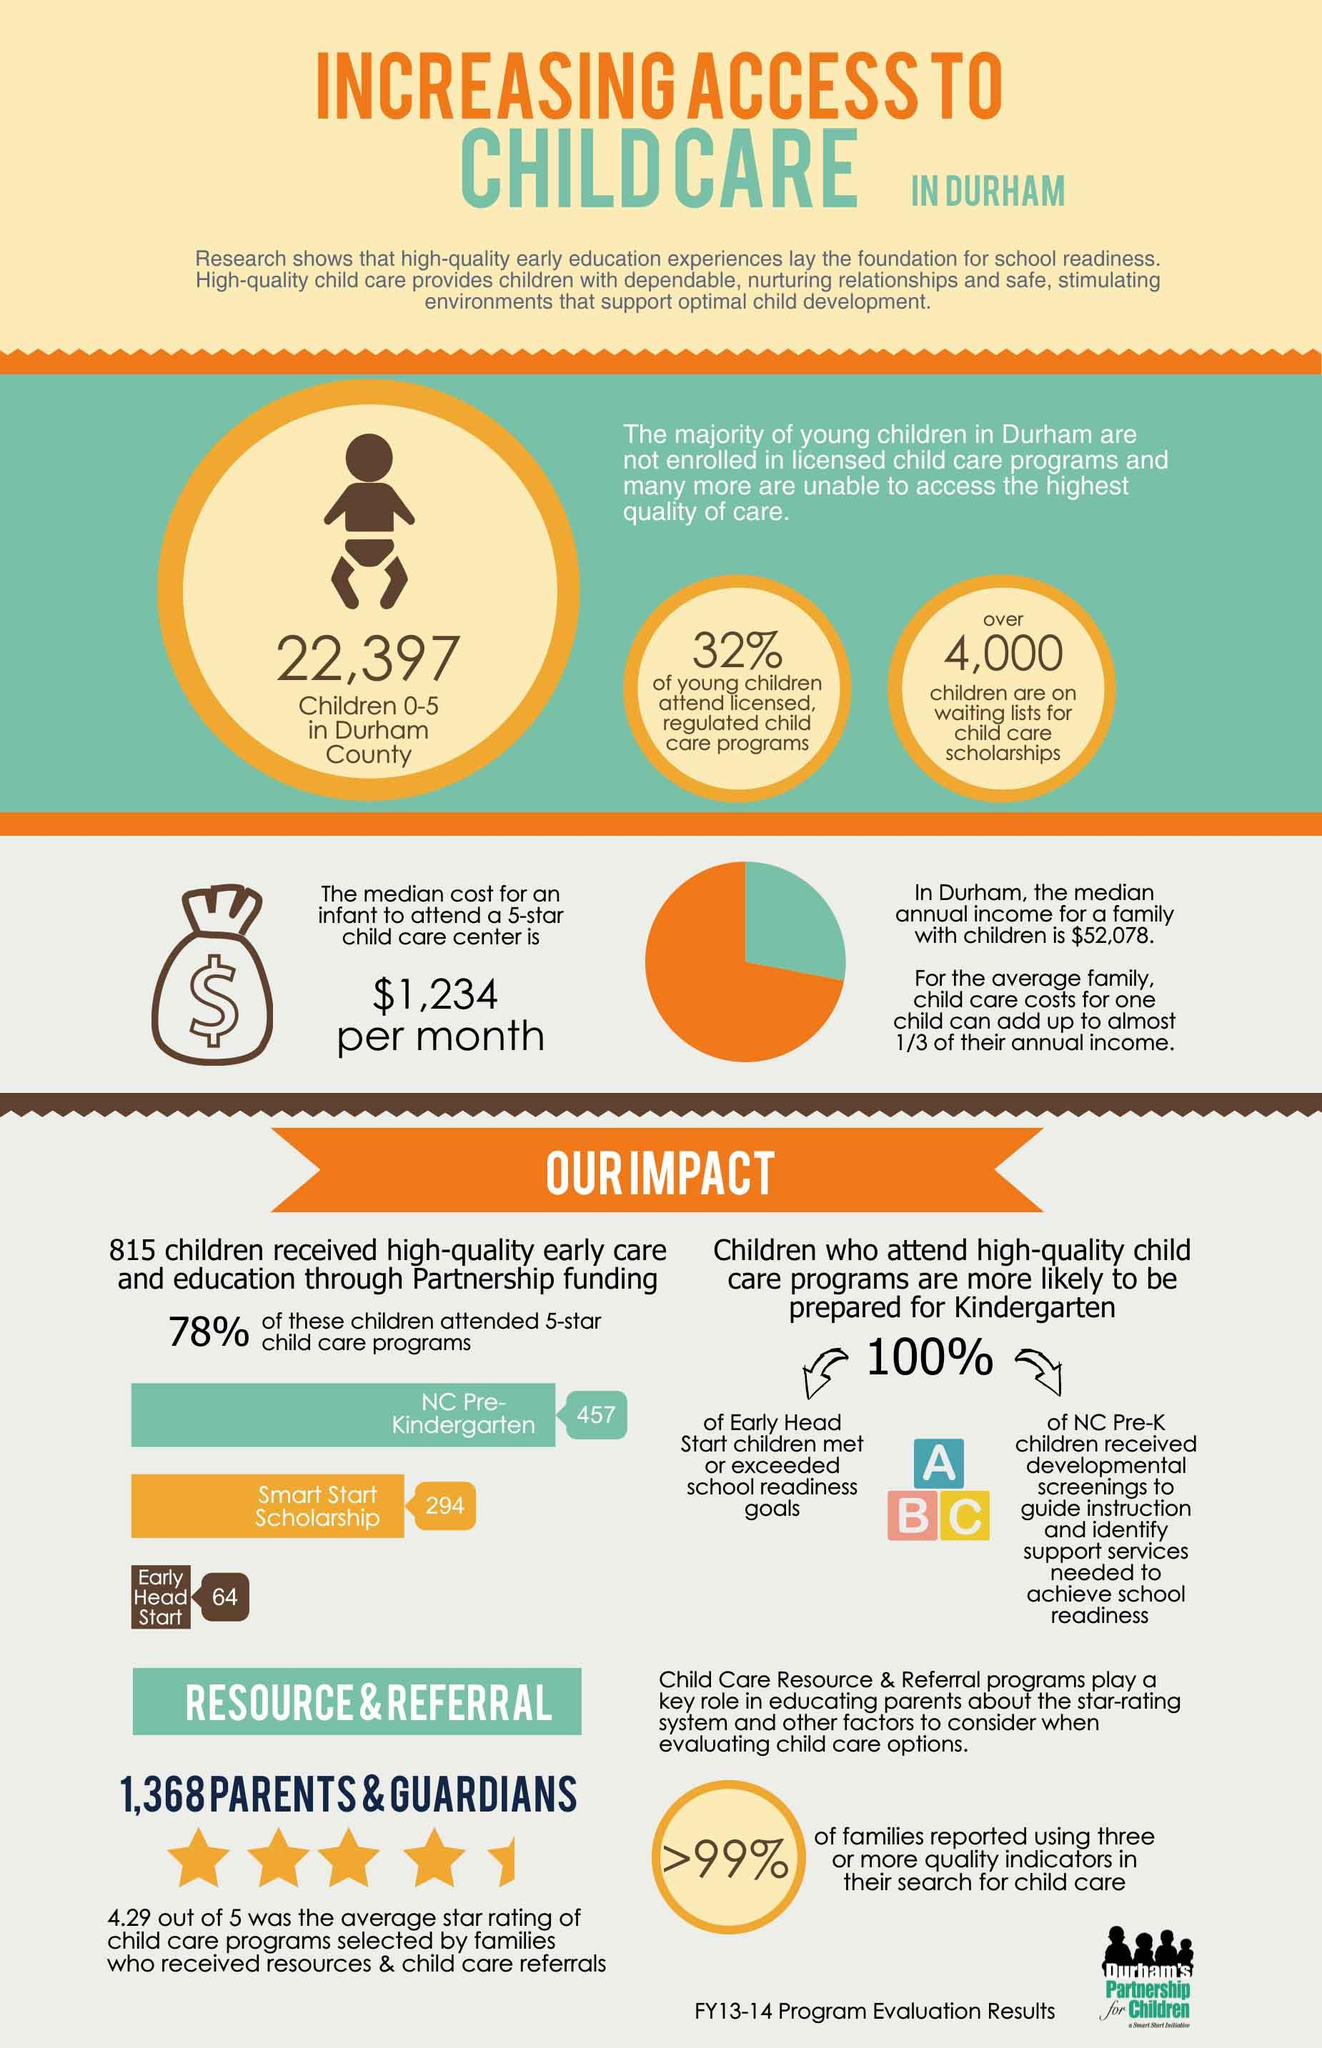Mention a couple of crucial points in this snapshot. During the 2013-14 fiscal year, 64 children in Durham attended the Early Head Start program. During the 2013-14 fiscal year, 32% of young children in Durham attended licensed and regulated child care programs. 